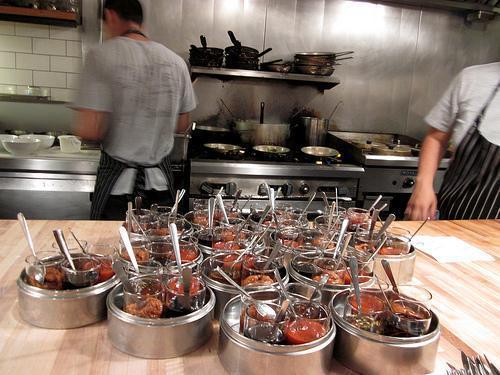How many cooks are there?
Give a very brief answer. 2. 